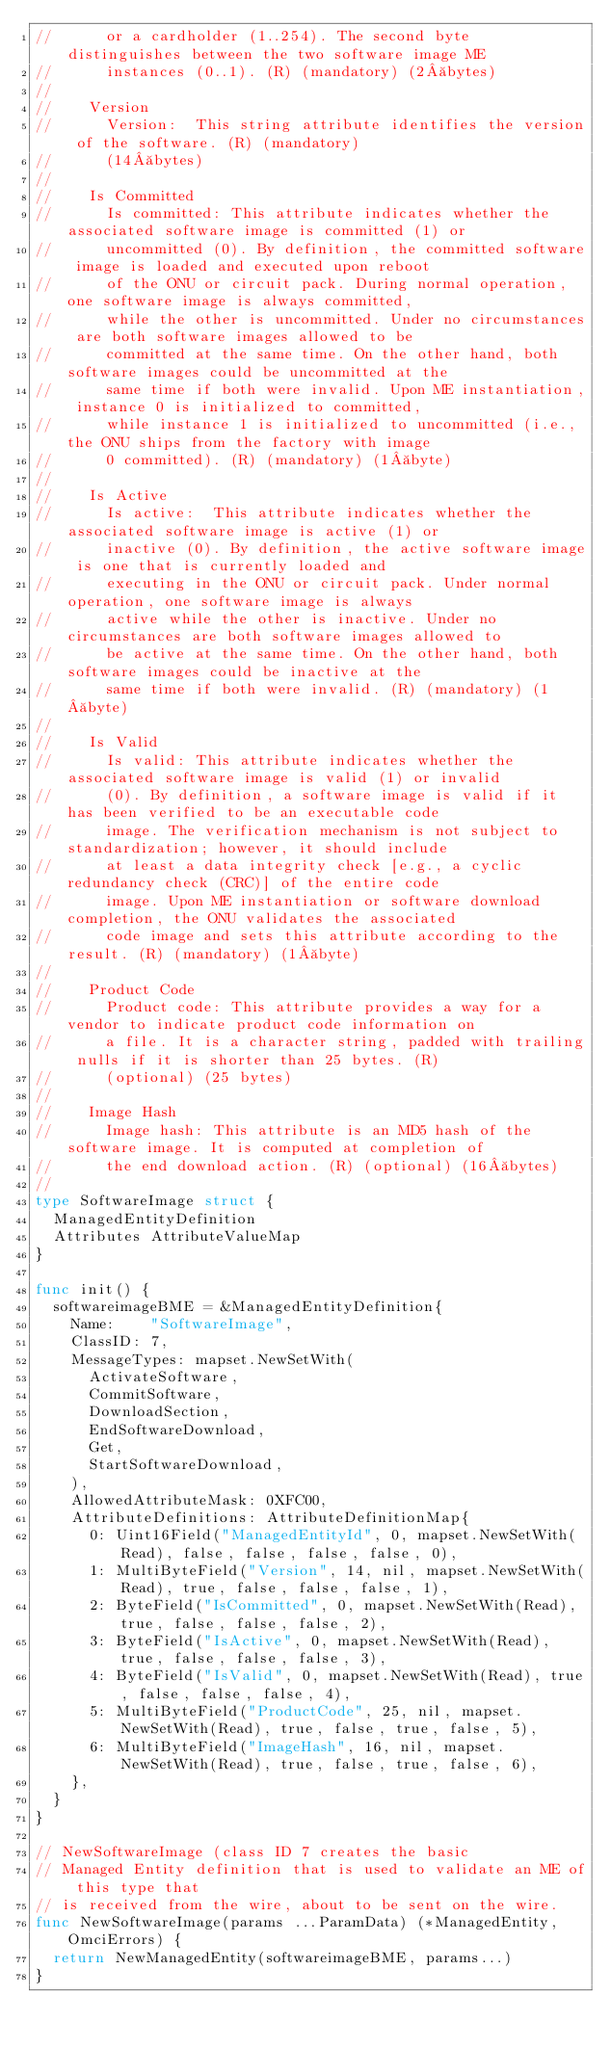<code> <loc_0><loc_0><loc_500><loc_500><_Go_>//			or a cardholder (1..254). The second byte distinguishes between the two software image ME
//			instances (0..1). (R) (mandatory) (2 bytes)
//
//		Version
//			Version:	This string attribute identifies the version of the software. (R) (mandatory)
//			(14 bytes)
//
//		Is Committed
//			Is committed: This attribute indicates whether the associated software image is committed (1) or
//			uncommitted (0). By definition, the committed software image is loaded and executed upon reboot
//			of the ONU or circuit pack. During normal operation, one software image is always committed,
//			while the other is uncommitted. Under no circumstances are both software images allowed to be
//			committed at the same time. On the other hand, both software images could be uncommitted at the
//			same time if both were invalid. Upon ME instantiation, instance 0 is initialized to committed,
//			while instance 1 is initialized to uncommitted (i.e., the ONU ships from the factory with image
//			0 committed). (R) (mandatory) (1 byte)
//
//		Is Active
//			Is active:	This attribute indicates whether the associated software image is active (1) or
//			inactive (0). By definition, the active software image is one that is currently loaded and
//			executing in the ONU or circuit pack. Under normal operation, one software image is always
//			active while the other is inactive. Under no circumstances are both software images allowed to
//			be active at the same time. On the other hand, both software images could be inactive at the
//			same time if both were invalid. (R) (mandatory) (1 byte)
//
//		Is Valid
//			Is valid:	This attribute indicates whether the associated software image is valid (1) or invalid
//			(0). By definition, a software image is valid if it has been verified to be an executable code
//			image. The verification mechanism is not subject to standardization; however, it should include
//			at least a data integrity check [e.g., a cyclic redundancy check (CRC)] of the entire code
//			image. Upon ME instantiation or software download completion, the ONU validates the associated
//			code image and sets this attribute according to the result. (R) (mandatory) (1 byte)
//
//		Product Code
//			Product code:	This attribute provides a way for a vendor to indicate product code information on
//			a file. It is a character string, padded with trailing nulls if it is shorter than 25 bytes. (R)
//			(optional) (25 bytes)
//
//		Image Hash
//			Image hash:	This attribute is an MD5 hash of the software image. It is computed at completion of
//			the end download action. (R) (optional) (16 bytes)
//
type SoftwareImage struct {
	ManagedEntityDefinition
	Attributes AttributeValueMap
}

func init() {
	softwareimageBME = &ManagedEntityDefinition{
		Name:    "SoftwareImage",
		ClassID: 7,
		MessageTypes: mapset.NewSetWith(
			ActivateSoftware,
			CommitSoftware,
			DownloadSection,
			EndSoftwareDownload,
			Get,
			StartSoftwareDownload,
		),
		AllowedAttributeMask: 0XFC00,
		AttributeDefinitions: AttributeDefinitionMap{
			0: Uint16Field("ManagedEntityId", 0, mapset.NewSetWith(Read), false, false, false, false, 0),
			1: MultiByteField("Version", 14, nil, mapset.NewSetWith(Read), true, false, false, false, 1),
			2: ByteField("IsCommitted", 0, mapset.NewSetWith(Read), true, false, false, false, 2),
			3: ByteField("IsActive", 0, mapset.NewSetWith(Read), true, false, false, false, 3),
			4: ByteField("IsValid", 0, mapset.NewSetWith(Read), true, false, false, false, 4),
			5: MultiByteField("ProductCode", 25, nil, mapset.NewSetWith(Read), true, false, true, false, 5),
			6: MultiByteField("ImageHash", 16, nil, mapset.NewSetWith(Read), true, false, true, false, 6),
		},
	}
}

// NewSoftwareImage (class ID 7 creates the basic
// Managed Entity definition that is used to validate an ME of this type that
// is received from the wire, about to be sent on the wire.
func NewSoftwareImage(params ...ParamData) (*ManagedEntity, OmciErrors) {
	return NewManagedEntity(softwareimageBME, params...)
}
</code> 